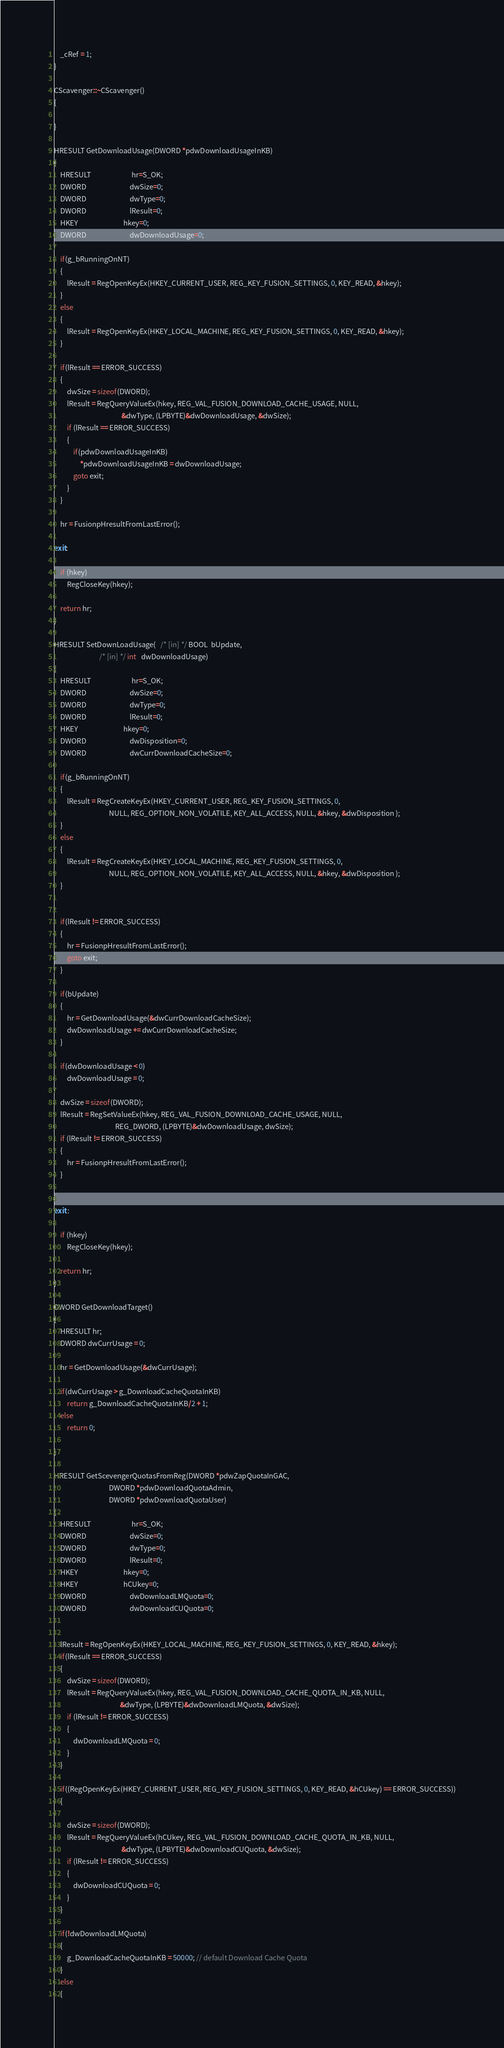<code> <loc_0><loc_0><loc_500><loc_500><_C++_>    _cRef = 1;
}

CScavenger::~CScavenger()
{

}

HRESULT GetDownloadUsage(DWORD *pdwDownloadUsageInKB)
{
    HRESULT                         hr=S_OK;
    DWORD                           dwSize=0;
    DWORD                           dwType=0;
    DWORD                           lResult=0;
    HKEY                            hkey=0;
    DWORD                           dwDownloadUsage=0;

    if(g_bRunningOnNT)
    {
        lResult = RegOpenKeyEx(HKEY_CURRENT_USER, REG_KEY_FUSION_SETTINGS, 0, KEY_READ, &hkey);
    }
    else
    {
        lResult = RegOpenKeyEx(HKEY_LOCAL_MACHINE, REG_KEY_FUSION_SETTINGS, 0, KEY_READ, &hkey);
    }

    if(lResult == ERROR_SUCCESS) 
    {
        dwSize = sizeof(DWORD);
        lResult = RegQueryValueEx(hkey, REG_VAL_FUSION_DOWNLOAD_CACHE_USAGE, NULL,
                                          &dwType, (LPBYTE)&dwDownloadUsage, &dwSize);
        if (lResult == ERROR_SUCCESS) 
        {
            if(pdwDownloadUsageInKB)
                *pdwDownloadUsageInKB = dwDownloadUsage;
            goto exit;
        }
    }

    hr = FusionpHresultFromLastError();

exit:

    if (hkey) 
        RegCloseKey(hkey);

    return hr;
}

HRESULT SetDownLoadUsage(   /* [in] */ BOOL  bUpdate,
                            /* [in] */ int   dwDownloadUsage)
{
    HRESULT                         hr=S_OK;
    DWORD                           dwSize=0;
    DWORD                           dwType=0;
    DWORD                           lResult=0;
    HKEY                            hkey=0;
    DWORD                           dwDisposition=0;
    DWORD                           dwCurrDownloadCacheSize=0;

    if(g_bRunningOnNT)
    {
        lResult = RegCreateKeyEx(HKEY_CURRENT_USER, REG_KEY_FUSION_SETTINGS, 0, 
                                  NULL, REG_OPTION_NON_VOLATILE, KEY_ALL_ACCESS, NULL, &hkey, &dwDisposition );
    }
    else
    {
        lResult = RegCreateKeyEx(HKEY_LOCAL_MACHINE, REG_KEY_FUSION_SETTINGS, 0, 
                                  NULL, REG_OPTION_NON_VOLATILE, KEY_ALL_ACCESS, NULL, &hkey, &dwDisposition );
    }


    if(lResult != ERROR_SUCCESS) 
    {
        hr = FusionpHresultFromLastError();
        goto exit;
    }

    if(bUpdate)
    {
        hr = GetDownloadUsage(&dwCurrDownloadCacheSize);
        dwDownloadUsage += dwCurrDownloadCacheSize;
    }

    if(dwDownloadUsage < 0)
        dwDownloadUsage = 0;

    dwSize = sizeof(DWORD);
    lResult = RegSetValueEx(hkey, REG_VAL_FUSION_DOWNLOAD_CACHE_USAGE, NULL,
                                      REG_DWORD, (LPBYTE)&dwDownloadUsage, dwSize);
    if (lResult != ERROR_SUCCESS) 
    {
        hr = FusionpHresultFromLastError();
    }


exit :

    if (hkey)
        RegCloseKey(hkey);

    return hr;
}

DWORD GetDownloadTarget()
{
    HRESULT hr;
    DWORD dwCurrUsage = 0;

    hr = GetDownloadUsage(&dwCurrUsage);

    if(dwCurrUsage > g_DownloadCacheQuotaInKB)
        return g_DownloadCacheQuotaInKB/2 + 1;
    else
        return 0;

}

HRESULT GetScevengerQuotasFromReg(DWORD *pdwZapQuotaInGAC,
                                  DWORD *pdwDownloadQuotaAdmin,
                                  DWORD *pdwDownloadQuotaUser)
{
    HRESULT                         hr=S_OK;
    DWORD                           dwSize=0;
    DWORD                           dwType=0;
    DWORD                           lResult=0;
    HKEY                            hkey=0;
    HKEY                            hCUkey=0;
    DWORD                           dwDownloadLMQuota=0;
    DWORD                           dwDownloadCUQuota=0;


    lResult = RegOpenKeyEx(HKEY_LOCAL_MACHINE, REG_KEY_FUSION_SETTINGS, 0, KEY_READ, &hkey);
    if(lResult == ERROR_SUCCESS) 
    {
        dwSize = sizeof(DWORD);
        lResult = RegQueryValueEx(hkey, REG_VAL_FUSION_DOWNLOAD_CACHE_QUOTA_IN_KB, NULL,
                                         &dwType, (LPBYTE)&dwDownloadLMQuota, &dwSize);
        if (lResult != ERROR_SUCCESS) 
        {
            dwDownloadLMQuota = 0;
        }
    }

    if((RegOpenKeyEx(HKEY_CURRENT_USER, REG_KEY_FUSION_SETTINGS, 0, KEY_READ, &hCUkey) == ERROR_SUCCESS))
    {

        dwSize = sizeof(DWORD);
        lResult = RegQueryValueEx(hCUkey, REG_VAL_FUSION_DOWNLOAD_CACHE_QUOTA_IN_KB, NULL,
                                          &dwType, (LPBYTE)&dwDownloadCUQuota, &dwSize);
        if (lResult != ERROR_SUCCESS) 
        {
            dwDownloadCUQuota = 0;
        }
    }

    if(!dwDownloadLMQuota)
    {
        g_DownloadCacheQuotaInKB = 50000; // default Download Cache Quota
    }
    else
    {</code> 